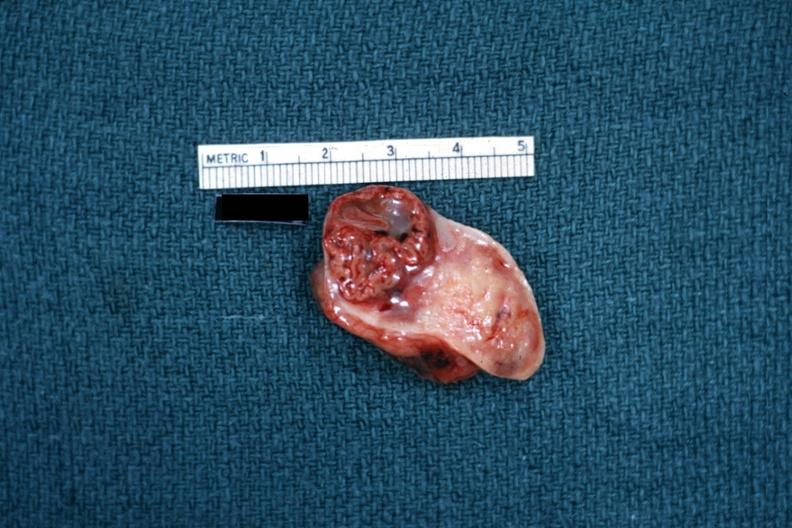what does this image show?
Answer the question using a single word or phrase. Excellent example close-up photo of corpus luteum 